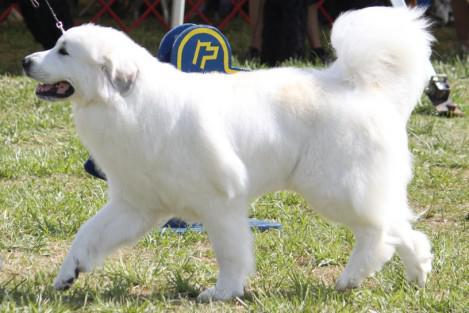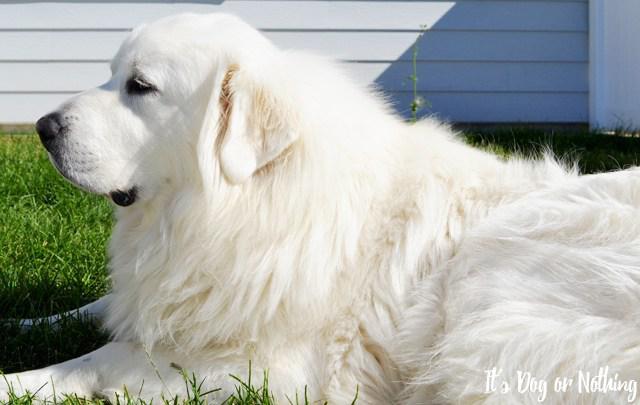The first image is the image on the left, the second image is the image on the right. For the images shown, is this caption "There is a single, white dog lying down in the right image." true? Answer yes or no. Yes. The first image is the image on the left, the second image is the image on the right. For the images displayed, is the sentence "If one dog is lying down, there are no sitting dogs near them." factually correct? Answer yes or no. Yes. 